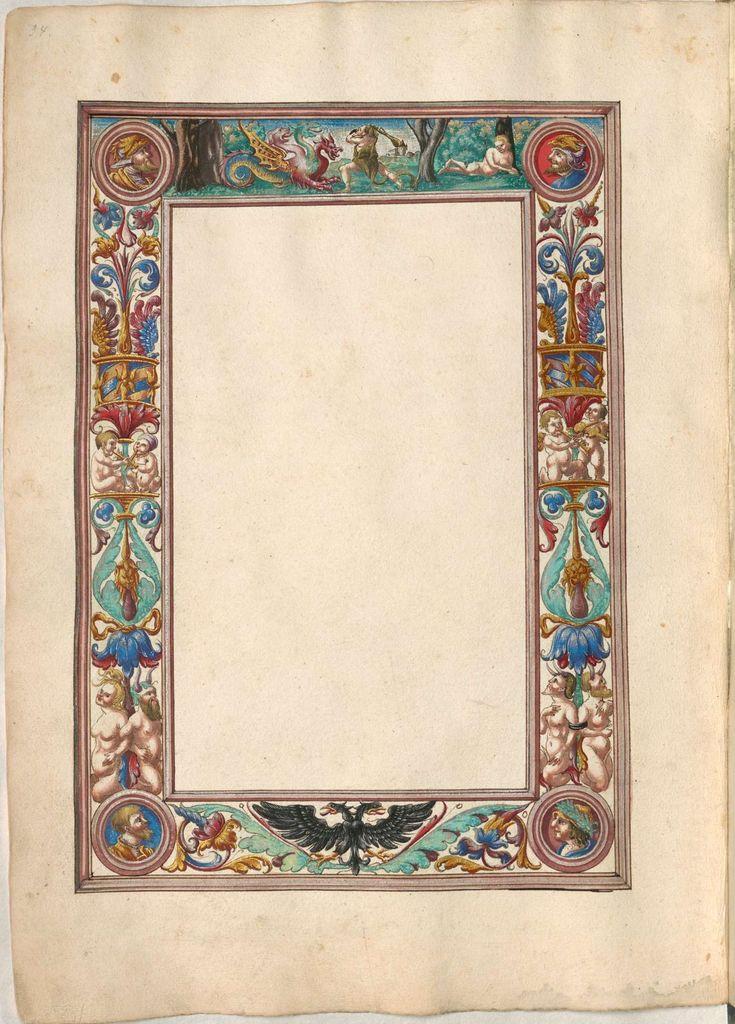Describe this image in one or two sentences. In this image I can see a cream colour thing and on it I can see different types of colourful paintings. 